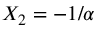Convert formula to latex. <formula><loc_0><loc_0><loc_500><loc_500>X _ { 2 } = - 1 / \alpha</formula> 